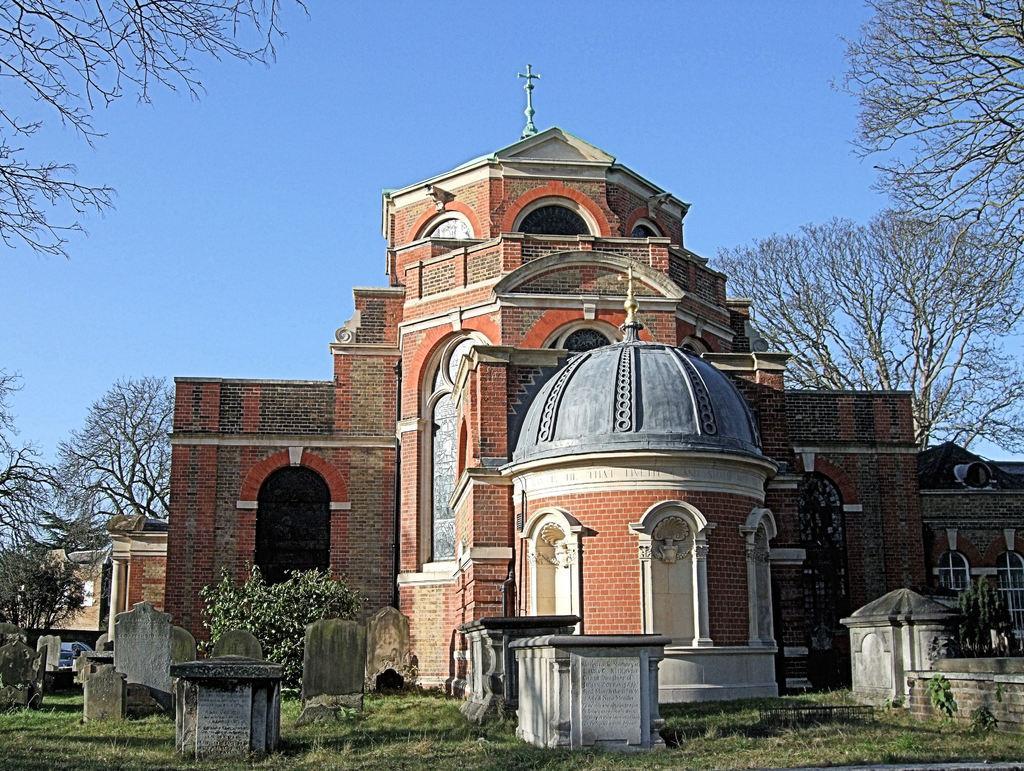In one or two sentences, can you explain what this image depicts? In this picture we can see some buildings, in front of the building we can see some cemeteries, grass and trees. 